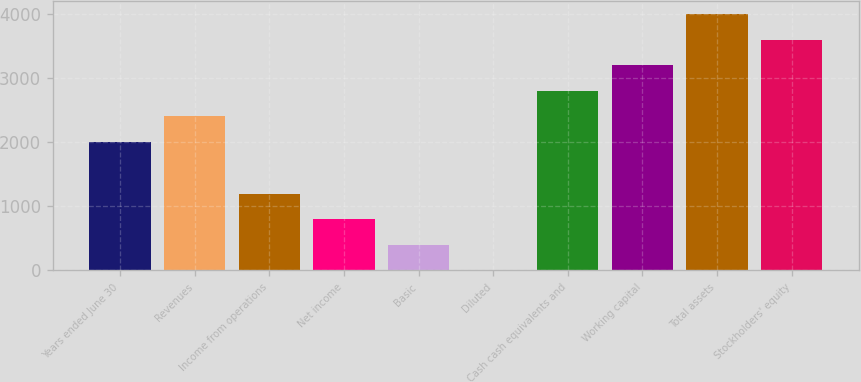<chart> <loc_0><loc_0><loc_500><loc_500><bar_chart><fcel>Years ended June 30<fcel>Revenues<fcel>Income from operations<fcel>Net income<fcel>Basic<fcel>Diluted<fcel>Cash cash equivalents and<fcel>Working capital<fcel>Total assets<fcel>Stockholders' equity<nl><fcel>2005<fcel>2403.37<fcel>1197.43<fcel>799.06<fcel>400.69<fcel>2.32<fcel>2801.74<fcel>3200.11<fcel>3996.85<fcel>3598.48<nl></chart> 